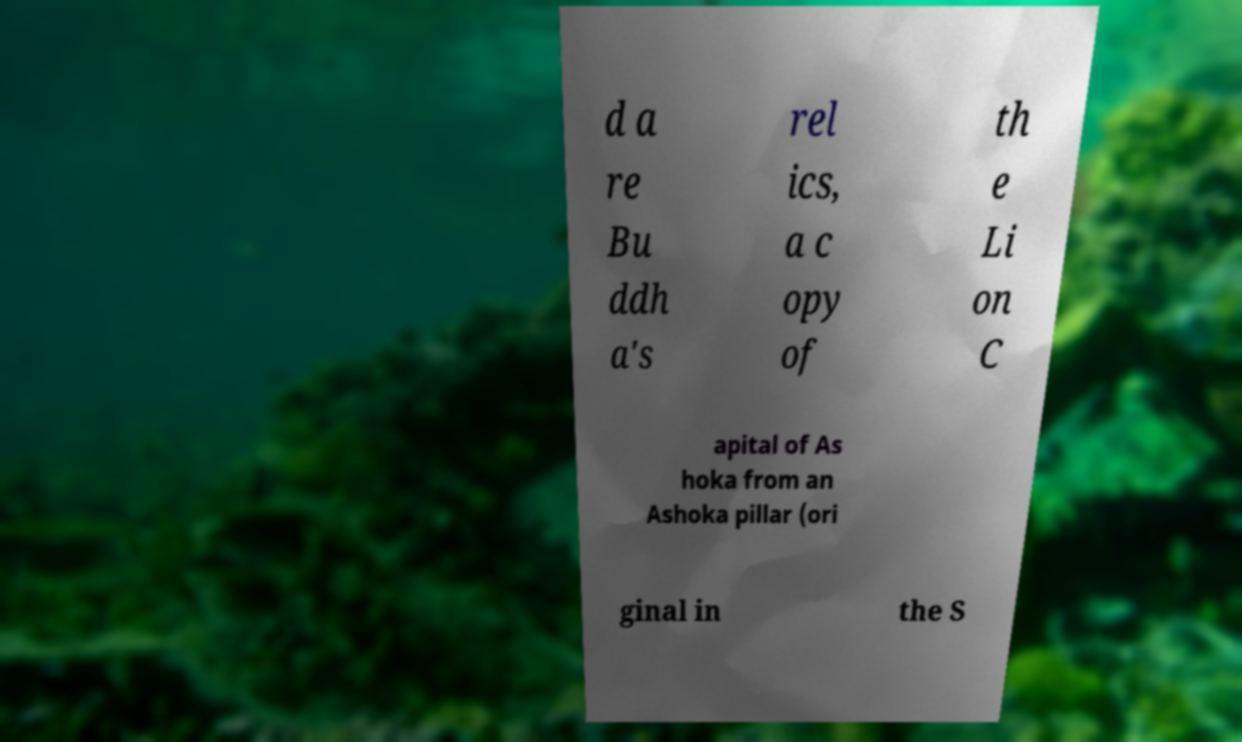What messages or text are displayed in this image? I need them in a readable, typed format. d a re Bu ddh a's rel ics, a c opy of th e Li on C apital of As hoka from an Ashoka pillar (ori ginal in the S 